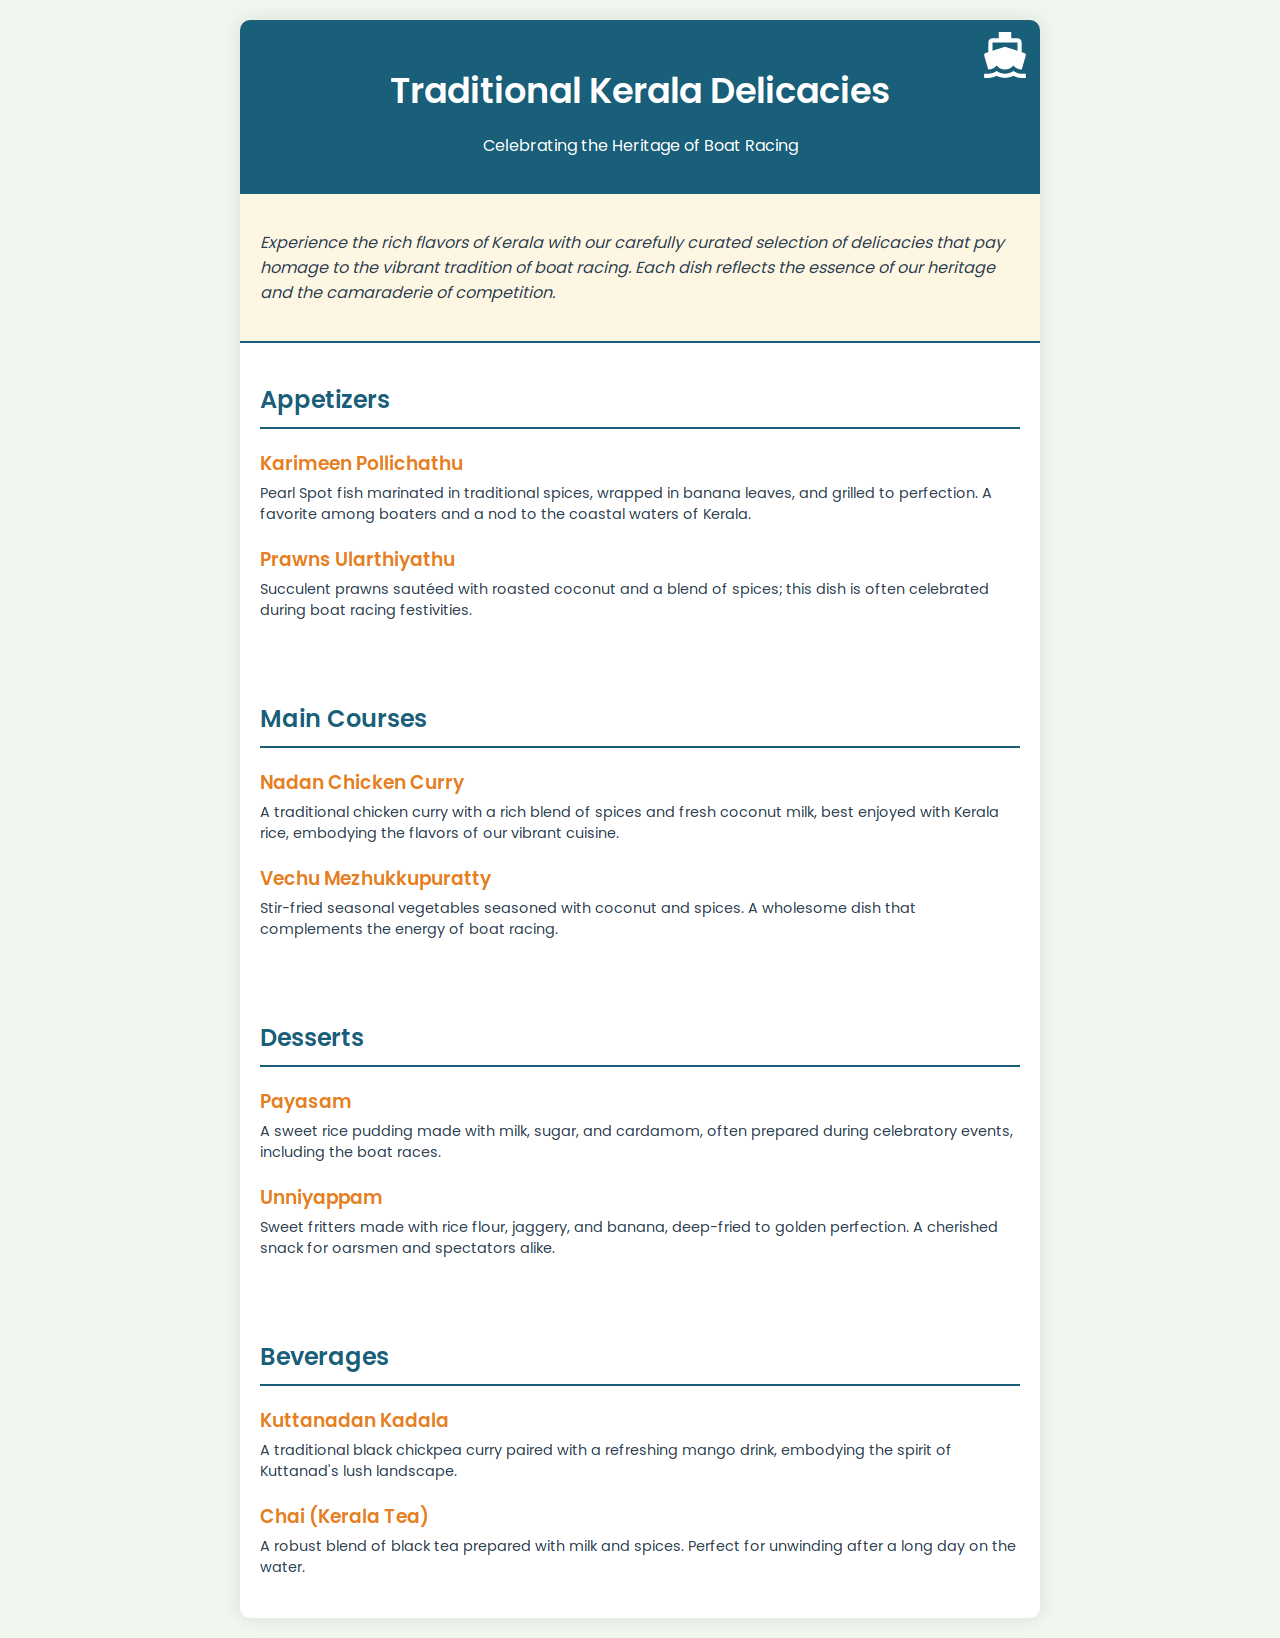What is the title of the menu? The title presents the main theme of the document, which is the culinary focus on traditional foods from Kerala.
Answer: Traditional Kerala Delicacies What is the first appetizer listed? The appetizers section features dishes that are typically served at the start of a meal, and the first one listed is the highlight.
Answer: Karimeen Pollichathu What type of fish is used in Karimeen Pollichathu? The menu specifies the type of fish that is the key ingredient in the preparation, important for understanding the dish's uniqueness.
Answer: Pearl Spot What dessert is considered a sweet rice pudding? This dessert is a popular dish often served at celebrations, and its description helps identify it clearly on the menu.
Answer: Payasam How many main courses are listed in the menu? The number of main courses provides insight into the variety offered on the menu, helping customers gauge options available.
Answer: Two Which beverage is described as a robust blend of black tea? The beverages section highlights drinks served at the restaurant, and this one describes a traditional tea.
Answer: Chai (Kerala Tea) What two textures are combined in Unniyappam? The description provides insight into the ingredients and cooking method that contribute to this snack's appeal.
Answer: Sweet fritters During which events is Payasam often prepared? This question explores the cultural significance of the dish, tied to celebrations and traditions noted in the menu.
Answer: Celebratory events What is the main ingredient in Prawns Ularthiyathu? Understanding the primary component in this dish clarifies what to expect in terms of flavor and cuisine style.
Answer: Prawns 